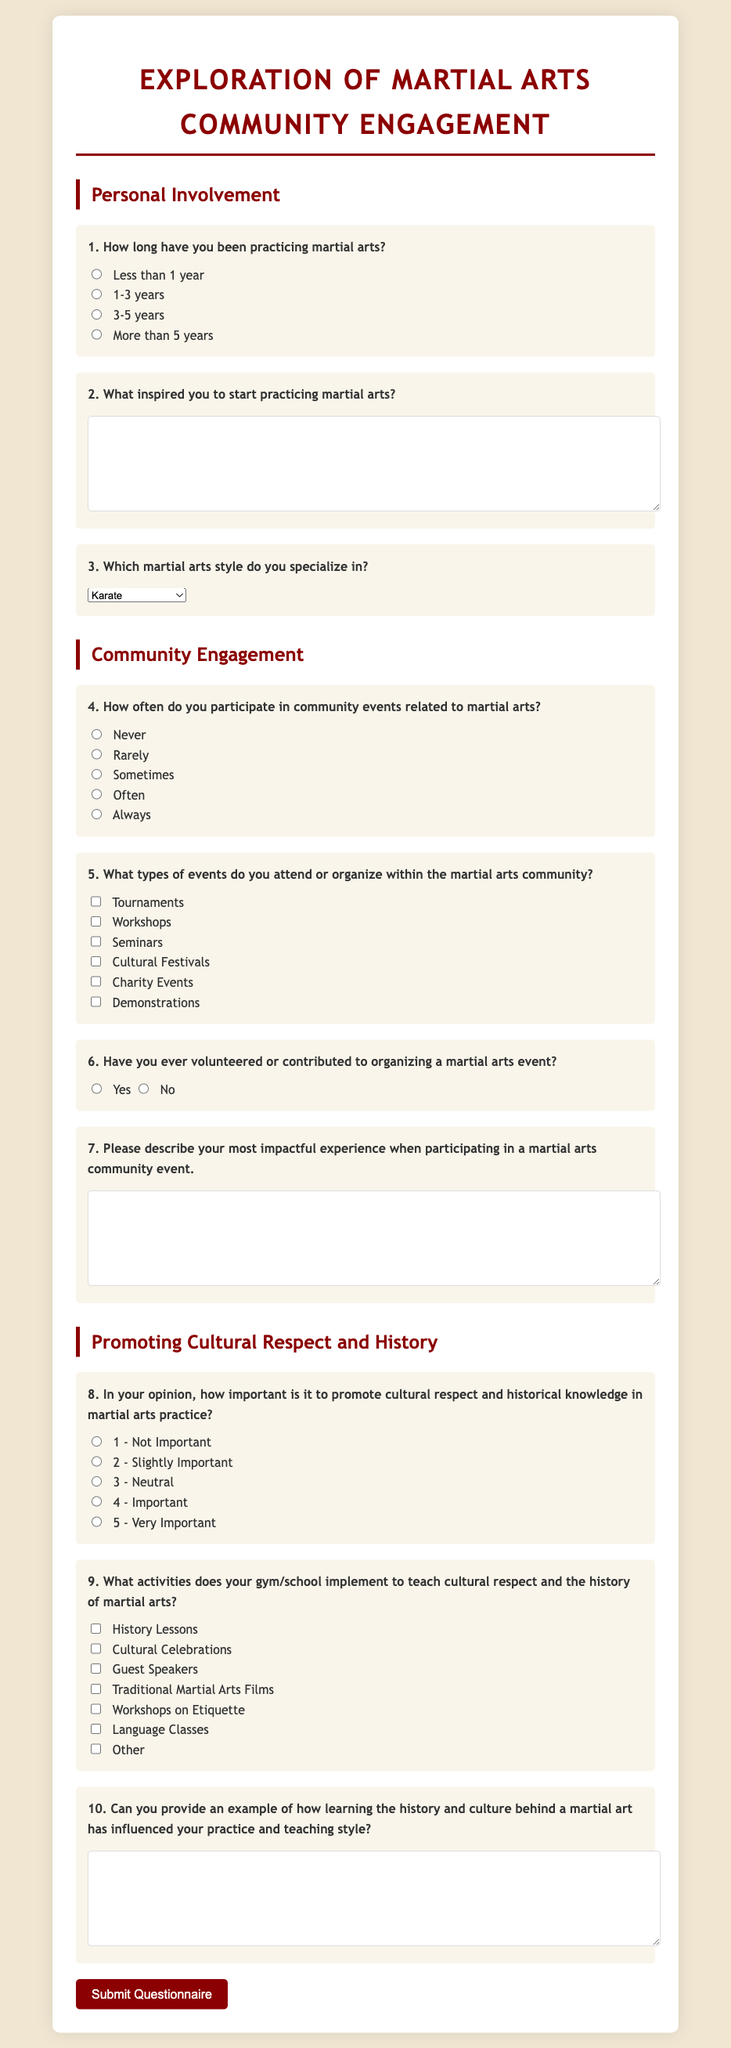What is the title of the questionnaire? The title of the questionnaire is stated prominently at the top of the document.
Answer: Exploration of Martial Arts Community Engagement How many main sections are in the questionnaire? The questionnaire is organized into different sections, which can be counted.
Answer: 3 What is the first question regarding personal involvement? The first question specifically asks about the duration of practicing martial arts.
Answer: How long have you been practicing martial arts? Which martial arts style is listed as an option in question 3? The document provides a dropdown list for martial arts styles, which includes various styles.
Answer: Karate How many frequency options are provided in question 4? The frequency of community event participation is gauged with several options to choose from.
Answer: 5 What importance rating is given in question 8? The significance of promoting cultural respect is rated on a scale in this question.
Answer: 1 - Not Important to 5 - Very Important What type of response does question 2 require? The second question asks for a personal reflection, which requires a descriptive response.
Answer: Short answer (text) How are cultural activities presented in question 9? Question 9 lists specific activities that can be checked off, showcasing community engagement.
Answer: Checkbox options What is the color of the submit button? The document includes styling details for the submit button, including its color.
Answer: Dark red 